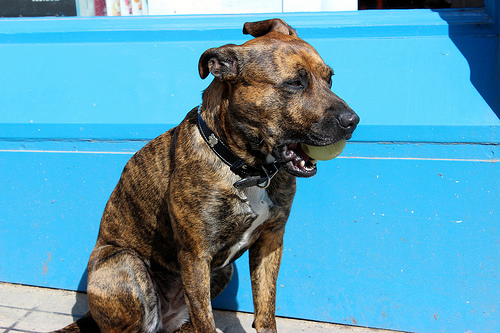<image>
Is there a dog behind the water? No. The dog is not behind the water. From this viewpoint, the dog appears to be positioned elsewhere in the scene. Where is the dog in relation to the ball? Is it next to the ball? No. The dog is not positioned next to the ball. They are located in different areas of the scene. Is the ball next to the dog? No. The ball is not positioned next to the dog. They are located in different areas of the scene. 